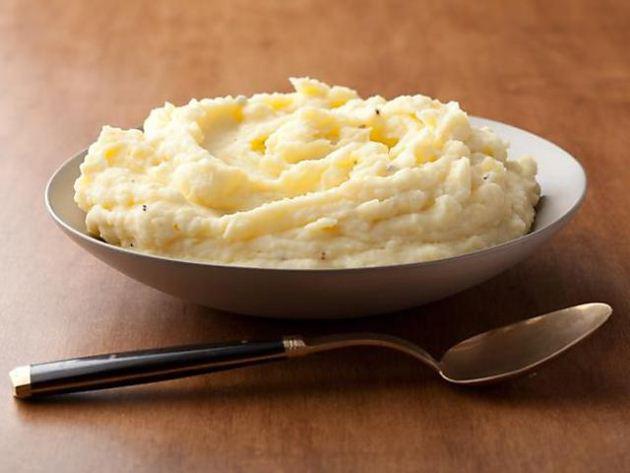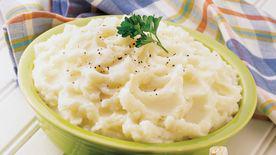The first image is the image on the left, the second image is the image on the right. Analyze the images presented: Is the assertion "One bowl of mashed potatoes is garnished with a green sprig and the other bowl appears ungarnished." valid? Answer yes or no. Yes. The first image is the image on the left, the second image is the image on the right. Evaluate the accuracy of this statement regarding the images: "At least one of the bowls is white.". Is it true? Answer yes or no. Yes. 